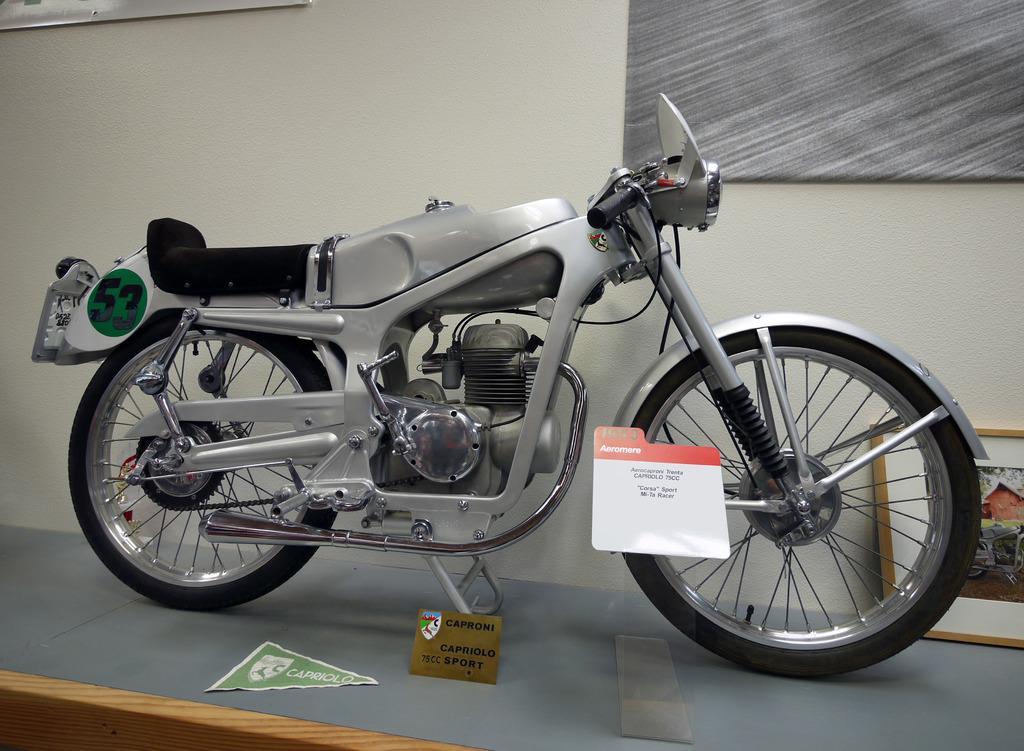Can you describe this image briefly? In this image there is a silver color bike standing on the table top. Behind there is a white color wall and a grey color fabric frame. 